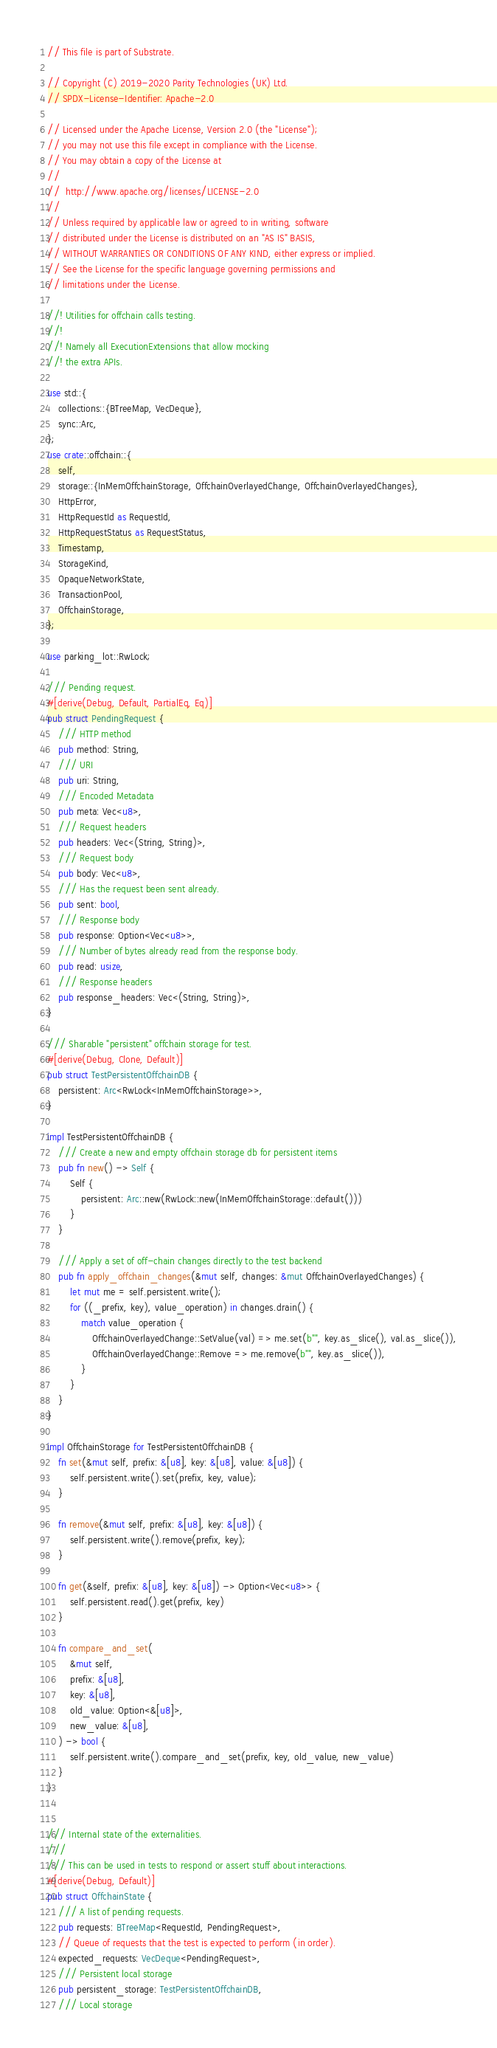<code> <loc_0><loc_0><loc_500><loc_500><_Rust_>// This file is part of Substrate.

// Copyright (C) 2019-2020 Parity Technologies (UK) Ltd.
// SPDX-License-Identifier: Apache-2.0

// Licensed under the Apache License, Version 2.0 (the "License");
// you may not use this file except in compliance with the License.
// You may obtain a copy of the License at
//
// 	http://www.apache.org/licenses/LICENSE-2.0
//
// Unless required by applicable law or agreed to in writing, software
// distributed under the License is distributed on an "AS IS" BASIS,
// WITHOUT WARRANTIES OR CONDITIONS OF ANY KIND, either express or implied.
// See the License for the specific language governing permissions and
// limitations under the License.

//! Utilities for offchain calls testing.
//!
//! Namely all ExecutionExtensions that allow mocking
//! the extra APIs.

use std::{
	collections::{BTreeMap, VecDeque},
	sync::Arc,
};
use crate::offchain::{
	self,
	storage::{InMemOffchainStorage, OffchainOverlayedChange, OffchainOverlayedChanges},
	HttpError,
	HttpRequestId as RequestId,
	HttpRequestStatus as RequestStatus,
	Timestamp,
	StorageKind,
	OpaqueNetworkState,
	TransactionPool,
	OffchainStorage,
};

use parking_lot::RwLock;

/// Pending request.
#[derive(Debug, Default, PartialEq, Eq)]
pub struct PendingRequest {
	/// HTTP method
	pub method: String,
	/// URI
	pub uri: String,
	/// Encoded Metadata
	pub meta: Vec<u8>,
	/// Request headers
	pub headers: Vec<(String, String)>,
	/// Request body
	pub body: Vec<u8>,
	/// Has the request been sent already.
	pub sent: bool,
	/// Response body
	pub response: Option<Vec<u8>>,
	/// Number of bytes already read from the response body.
	pub read: usize,
	/// Response headers
	pub response_headers: Vec<(String, String)>,
}

/// Sharable "persistent" offchain storage for test.
#[derive(Debug, Clone, Default)]
pub struct TestPersistentOffchainDB {
	persistent: Arc<RwLock<InMemOffchainStorage>>,
}

impl TestPersistentOffchainDB {
	/// Create a new and empty offchain storage db for persistent items
	pub fn new() -> Self {
		Self {
			persistent: Arc::new(RwLock::new(InMemOffchainStorage::default()))
		}
	}

	/// Apply a set of off-chain changes directly to the test backend
	pub fn apply_offchain_changes(&mut self, changes: &mut OffchainOverlayedChanges) {
		let mut me = self.persistent.write();
		for ((_prefix, key), value_operation) in changes.drain() {
			match value_operation {
				OffchainOverlayedChange::SetValue(val) => me.set(b"", key.as_slice(), val.as_slice()),
				OffchainOverlayedChange::Remove => me.remove(b"", key.as_slice()),
			}
		}
	}
}

impl OffchainStorage for TestPersistentOffchainDB {
	fn set(&mut self, prefix: &[u8], key: &[u8], value: &[u8]) {
		self.persistent.write().set(prefix, key, value);
	}

	fn remove(&mut self, prefix: &[u8], key: &[u8]) {
		self.persistent.write().remove(prefix, key);
	}

	fn get(&self, prefix: &[u8], key: &[u8]) -> Option<Vec<u8>> {
		self.persistent.read().get(prefix, key)
	}

	fn compare_and_set(
		&mut self,
		prefix: &[u8],
		key: &[u8],
		old_value: Option<&[u8]>,
		new_value: &[u8],
	) -> bool {
		self.persistent.write().compare_and_set(prefix, key, old_value, new_value)
	}
}


/// Internal state of the externalities.
///
/// This can be used in tests to respond or assert stuff about interactions.
#[derive(Debug, Default)]
pub struct OffchainState {
	/// A list of pending requests.
	pub requests: BTreeMap<RequestId, PendingRequest>,
	// Queue of requests that the test is expected to perform (in order).
	expected_requests: VecDeque<PendingRequest>,
	/// Persistent local storage
	pub persistent_storage: TestPersistentOffchainDB,
	/// Local storage</code> 